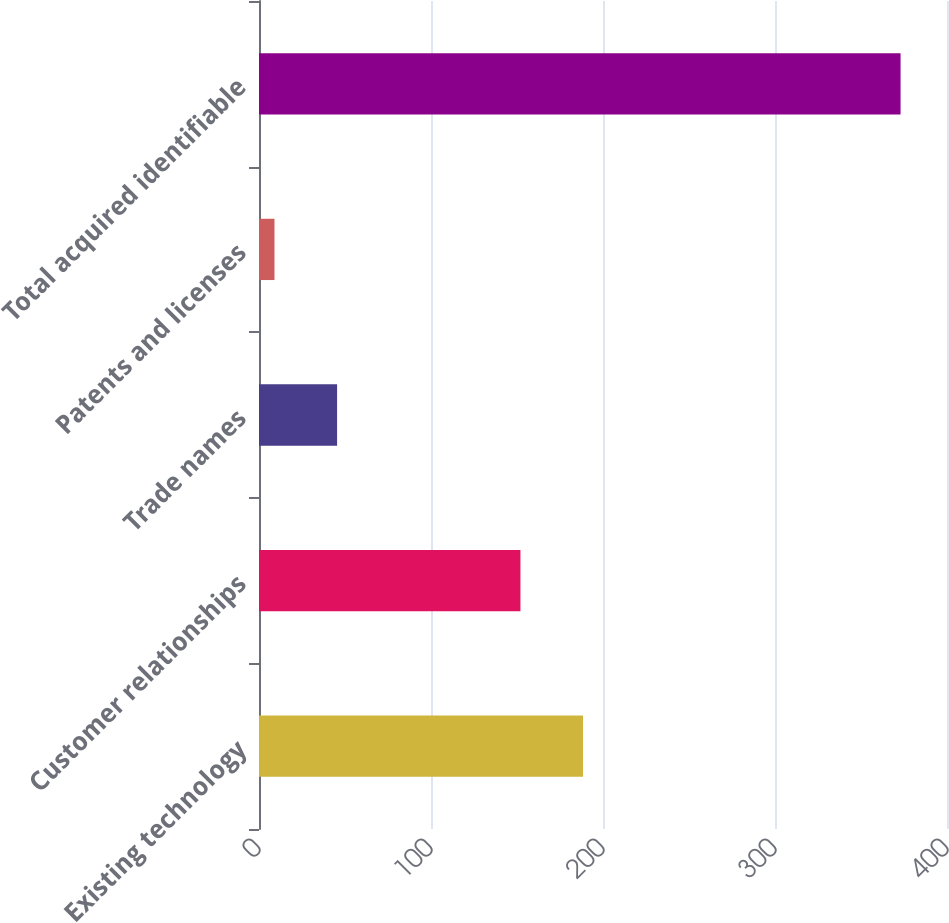Convert chart to OTSL. <chart><loc_0><loc_0><loc_500><loc_500><bar_chart><fcel>Existing technology<fcel>Customer relationships<fcel>Trade names<fcel>Patents and licenses<fcel>Total acquired identifiable<nl><fcel>188.4<fcel>152<fcel>45.4<fcel>9<fcel>373<nl></chart> 